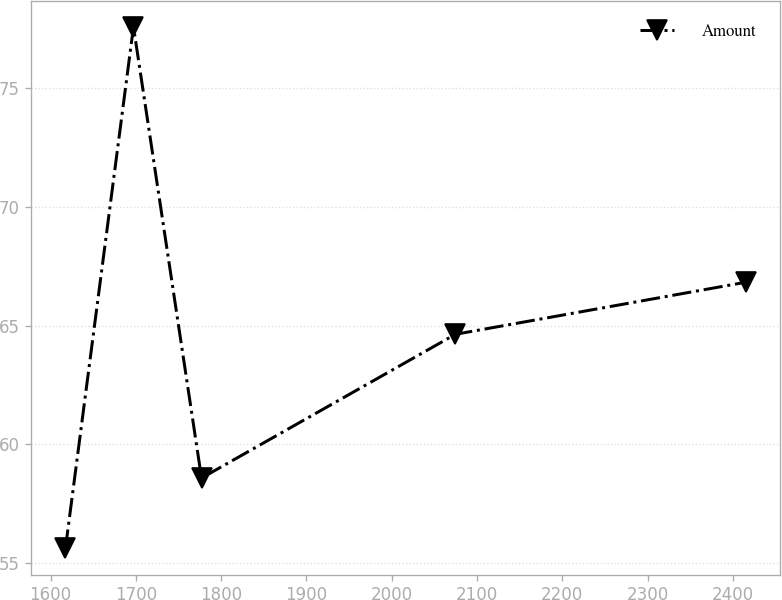<chart> <loc_0><loc_0><loc_500><loc_500><line_chart><ecel><fcel>Amount<nl><fcel>1617.49<fcel>55.63<nl><fcel>1697.28<fcel>77.55<nl><fcel>1777.07<fcel>58.59<nl><fcel>2074.66<fcel>64.63<nl><fcel>2415.4<fcel>66.82<nl></chart> 